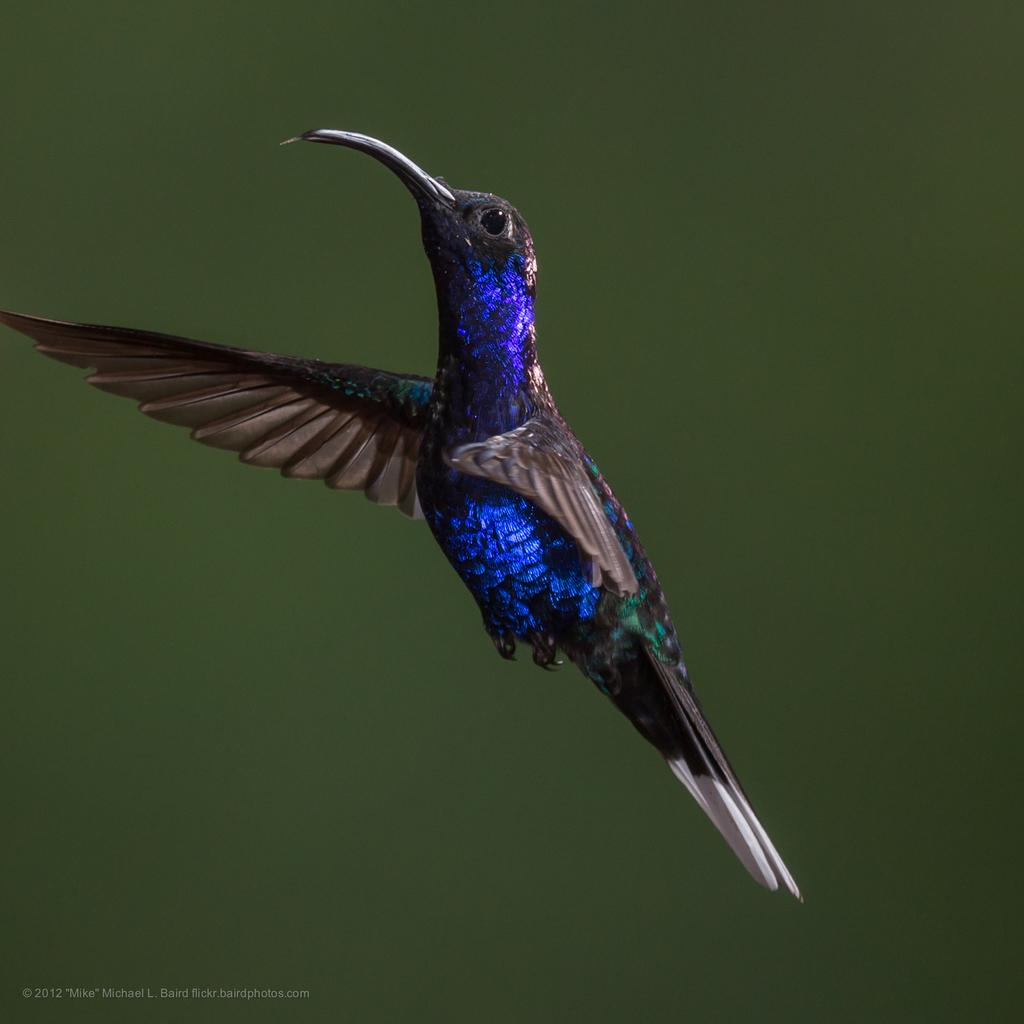What type of animal is in the image? There is a bird in the image. Can you describe the background of the image? The background of the image is blurred. What is the tendency of the flame in the image? There is no flame present in the image. How many arms does the bird have in the image? Birds typically have two wings, not arms, and there is only one bird visible in the image. 